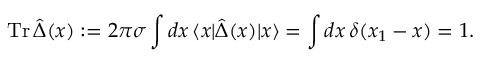Convert formula to latex. <formula><loc_0><loc_0><loc_500><loc_500>T r \, \hat { \Delta } ( x ) \colon = 2 \pi \sigma \int d x \, \langle x | \hat { \Delta } ( x ) | x \rangle = \int d x \, \delta ( x _ { 1 } - x ) = 1 .</formula> 